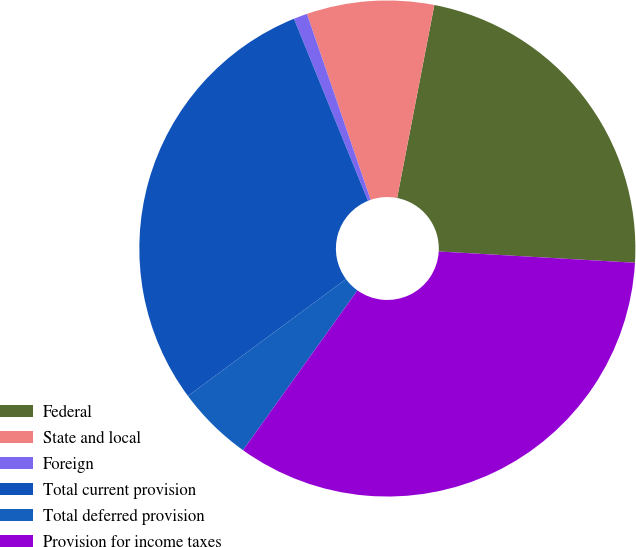<chart> <loc_0><loc_0><loc_500><loc_500><pie_chart><fcel>Federal<fcel>State and local<fcel>Foreign<fcel>Total current provision<fcel>Total deferred provision<fcel>Provision for income taxes<nl><fcel>22.88%<fcel>8.29%<fcel>0.89%<fcel>28.99%<fcel>4.98%<fcel>33.97%<nl></chart> 